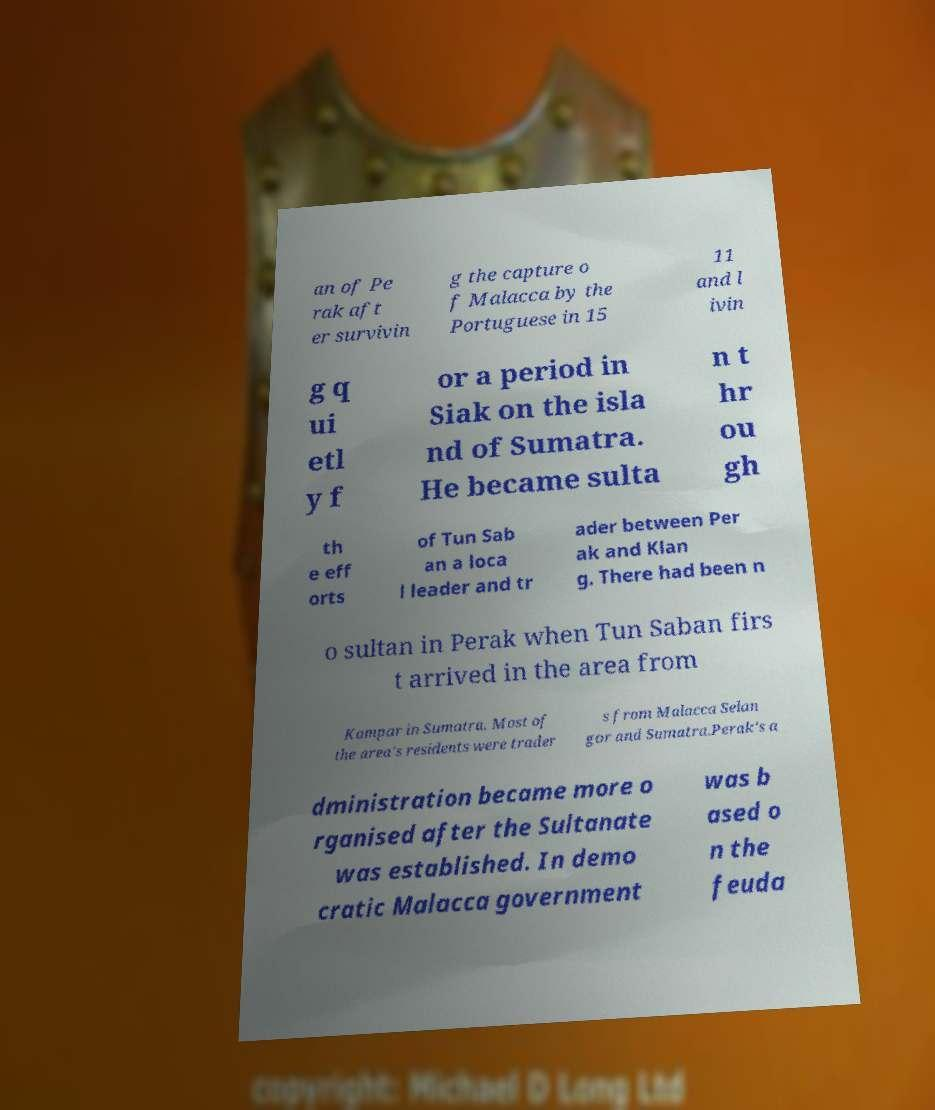Please identify and transcribe the text found in this image. an of Pe rak aft er survivin g the capture o f Malacca by the Portuguese in 15 11 and l ivin g q ui etl y f or a period in Siak on the isla nd of Sumatra. He became sulta n t hr ou gh th e eff orts of Tun Sab an a loca l leader and tr ader between Per ak and Klan g. There had been n o sultan in Perak when Tun Saban firs t arrived in the area from Kampar in Sumatra. Most of the area's residents were trader s from Malacca Selan gor and Sumatra.Perak's a dministration became more o rganised after the Sultanate was established. In demo cratic Malacca government was b ased o n the feuda 